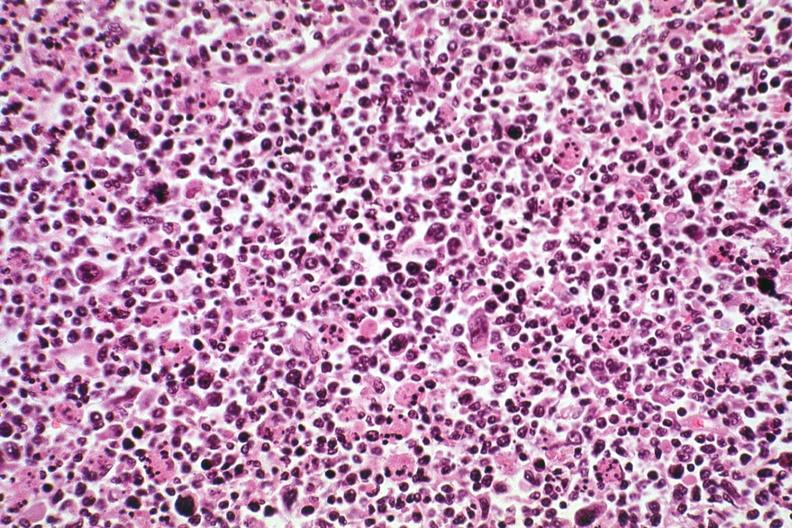does this image show pleomorphic see other slides this case?
Answer the question using a single word or phrase. Yes 